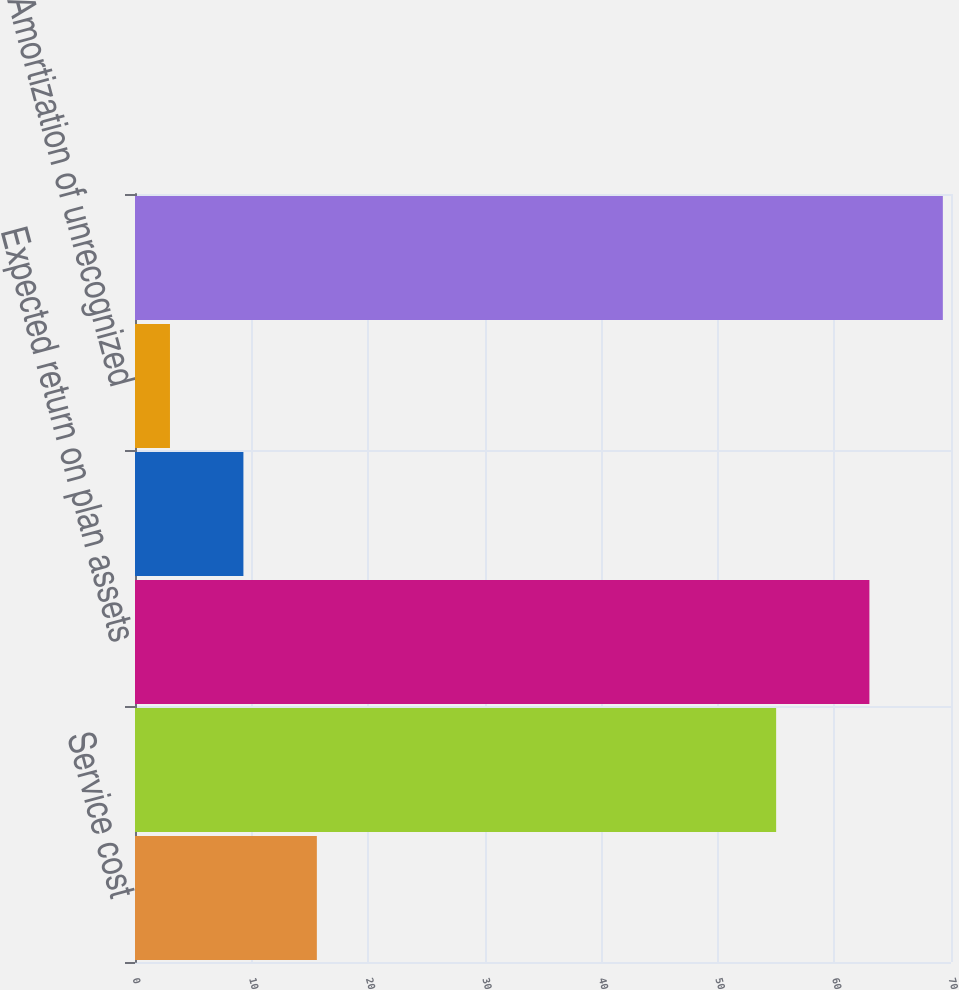Convert chart to OTSL. <chart><loc_0><loc_0><loc_500><loc_500><bar_chart><fcel>Service cost<fcel>Interest cost on projected<fcel>Expected return on plan assets<fcel>Amount of curtailment (gain)<fcel>Amortization of unrecognized<fcel>Total pension cost<nl><fcel>15.6<fcel>55<fcel>63<fcel>9.3<fcel>3<fcel>69.3<nl></chart> 